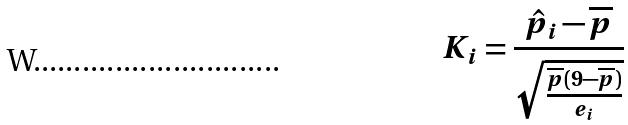<formula> <loc_0><loc_0><loc_500><loc_500>K _ { i } = \frac { \hat { p } _ { i } - \overline { p } } { \sqrt { \frac { \overline { p } ( 9 - \overline { p } ) } { e _ { i } } } }</formula> 